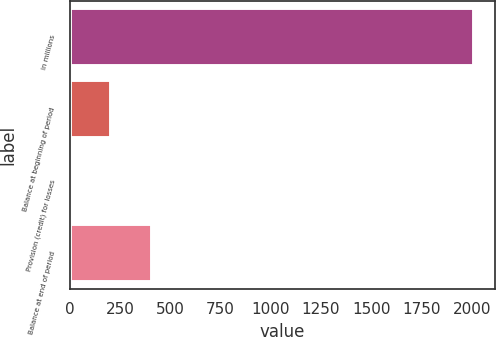Convert chart. <chart><loc_0><loc_0><loc_500><loc_500><bar_chart><fcel>in millions<fcel>Balance at beginning of period<fcel>Provision (credit) for losses<fcel>Balance at end of period<nl><fcel>2013<fcel>208.5<fcel>8<fcel>409<nl></chart> 